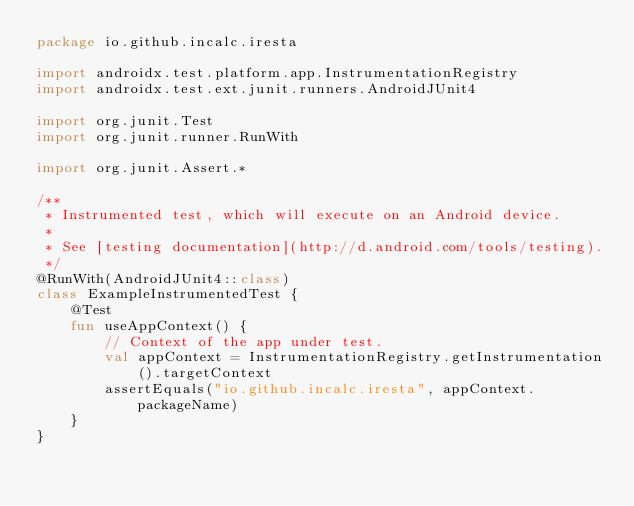<code> <loc_0><loc_0><loc_500><loc_500><_Kotlin_>package io.github.incalc.iresta

import androidx.test.platform.app.InstrumentationRegistry
import androidx.test.ext.junit.runners.AndroidJUnit4

import org.junit.Test
import org.junit.runner.RunWith

import org.junit.Assert.*

/**
 * Instrumented test, which will execute on an Android device.
 *
 * See [testing documentation](http://d.android.com/tools/testing).
 */
@RunWith(AndroidJUnit4::class)
class ExampleInstrumentedTest {
    @Test
    fun useAppContext() {
        // Context of the app under test.
        val appContext = InstrumentationRegistry.getInstrumentation().targetContext
        assertEquals("io.github.incalc.iresta", appContext.packageName)
    }
}
</code> 